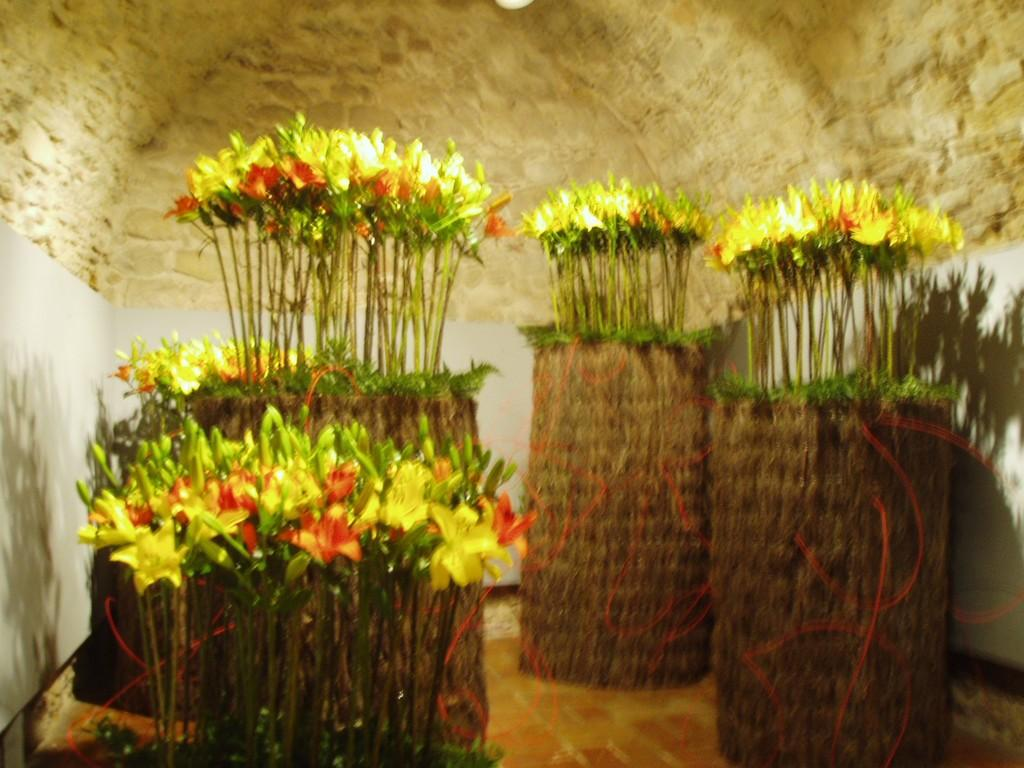What type of space is depicted in the image? The image shows an inside view of a room. What can be seen in the middle of the room? There are plants and flowers in the middle of the room. What part of the room is visible at the bottom of the image? The floor is visible at the bottom of the image. What type of skate is being used to measure the protest in the image? There is no skate, measurement, or protest present in the image. 